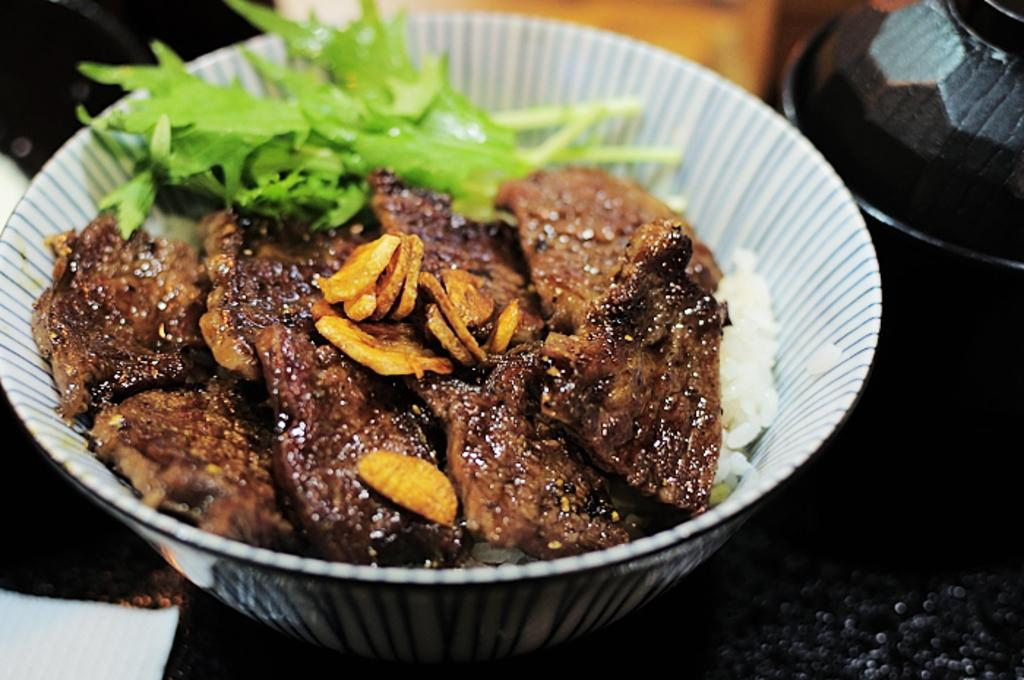What is in the bowl that is visible in the image? There are food items in a bowl in the image. Can you describe the other bowl on the table in the image? There is another bowl on the table in the image, but its contents are not specified. How does the airplane affect the cloud in the image? There is no airplane or cloud present in the image, so this question cannot be answered. 